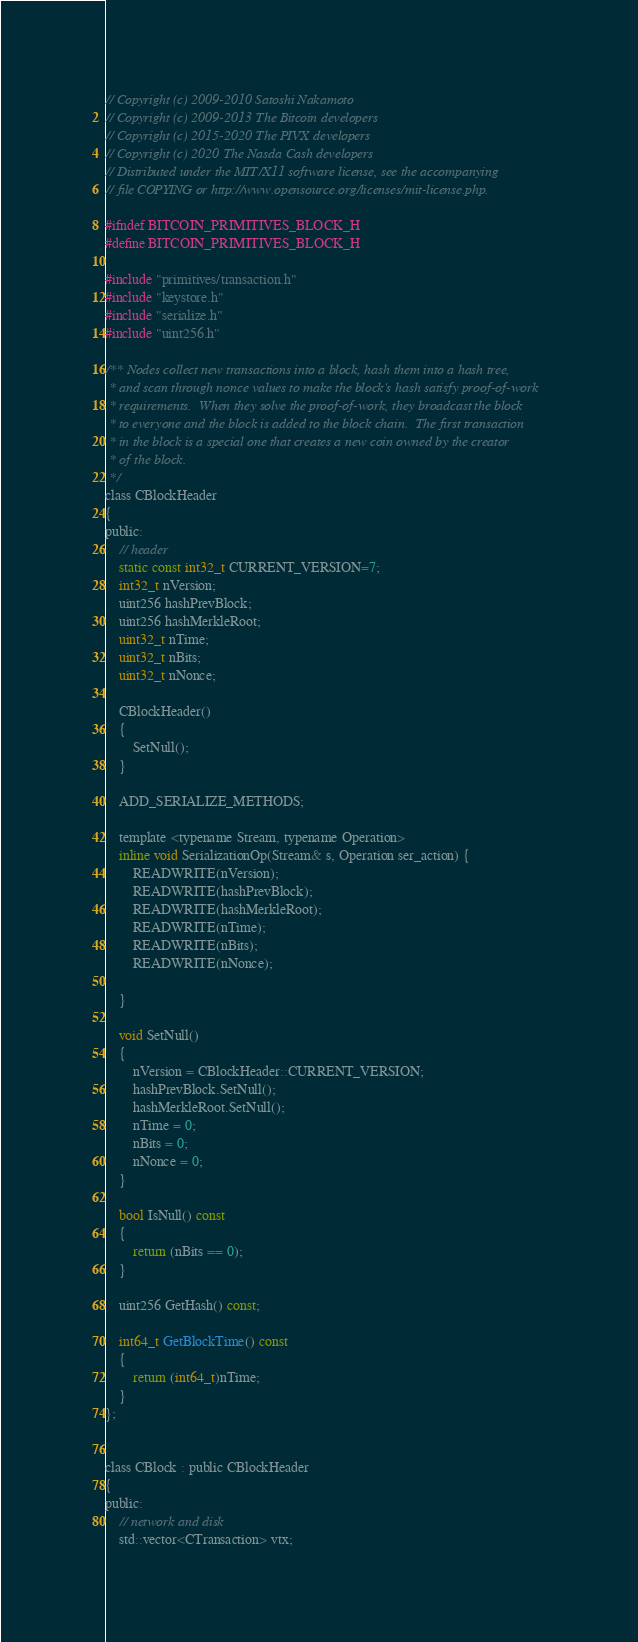Convert code to text. <code><loc_0><loc_0><loc_500><loc_500><_C_>// Copyright (c) 2009-2010 Satoshi Nakamoto
// Copyright (c) 2009-2013 The Bitcoin developers
// Copyright (c) 2015-2020 The PIVX developers
// Copyright (c) 2020 The Nasda Cash developers
// Distributed under the MIT/X11 software license, see the accompanying
// file COPYING or http://www.opensource.org/licenses/mit-license.php.

#ifndef BITCOIN_PRIMITIVES_BLOCK_H
#define BITCOIN_PRIMITIVES_BLOCK_H

#include "primitives/transaction.h"
#include "keystore.h"
#include "serialize.h"
#include "uint256.h"

/** Nodes collect new transactions into a block, hash them into a hash tree,
 * and scan through nonce values to make the block's hash satisfy proof-of-work
 * requirements.  When they solve the proof-of-work, they broadcast the block
 * to everyone and the block is added to the block chain.  The first transaction
 * in the block is a special one that creates a new coin owned by the creator
 * of the block.
 */
class CBlockHeader
{
public:
    // header
    static const int32_t CURRENT_VERSION=7;     
    int32_t nVersion;
    uint256 hashPrevBlock;
    uint256 hashMerkleRoot;
    uint32_t nTime;
    uint32_t nBits;
    uint32_t nNonce;

    CBlockHeader()
    {
        SetNull();
    }

    ADD_SERIALIZE_METHODS;

    template <typename Stream, typename Operation>
    inline void SerializationOp(Stream& s, Operation ser_action) {
        READWRITE(nVersion);
        READWRITE(hashPrevBlock);
        READWRITE(hashMerkleRoot);
        READWRITE(nTime);
        READWRITE(nBits);
        READWRITE(nNonce);

    }

    void SetNull()
    {
        nVersion = CBlockHeader::CURRENT_VERSION;
        hashPrevBlock.SetNull();
        hashMerkleRoot.SetNull();
        nTime = 0;
        nBits = 0;
        nNonce = 0;
    }

    bool IsNull() const
    {
        return (nBits == 0);
    }

    uint256 GetHash() const;

    int64_t GetBlockTime() const
    {
        return (int64_t)nTime;
    }
};


class CBlock : public CBlockHeader
{
public:
    // network and disk
    std::vector<CTransaction> vtx;
</code> 